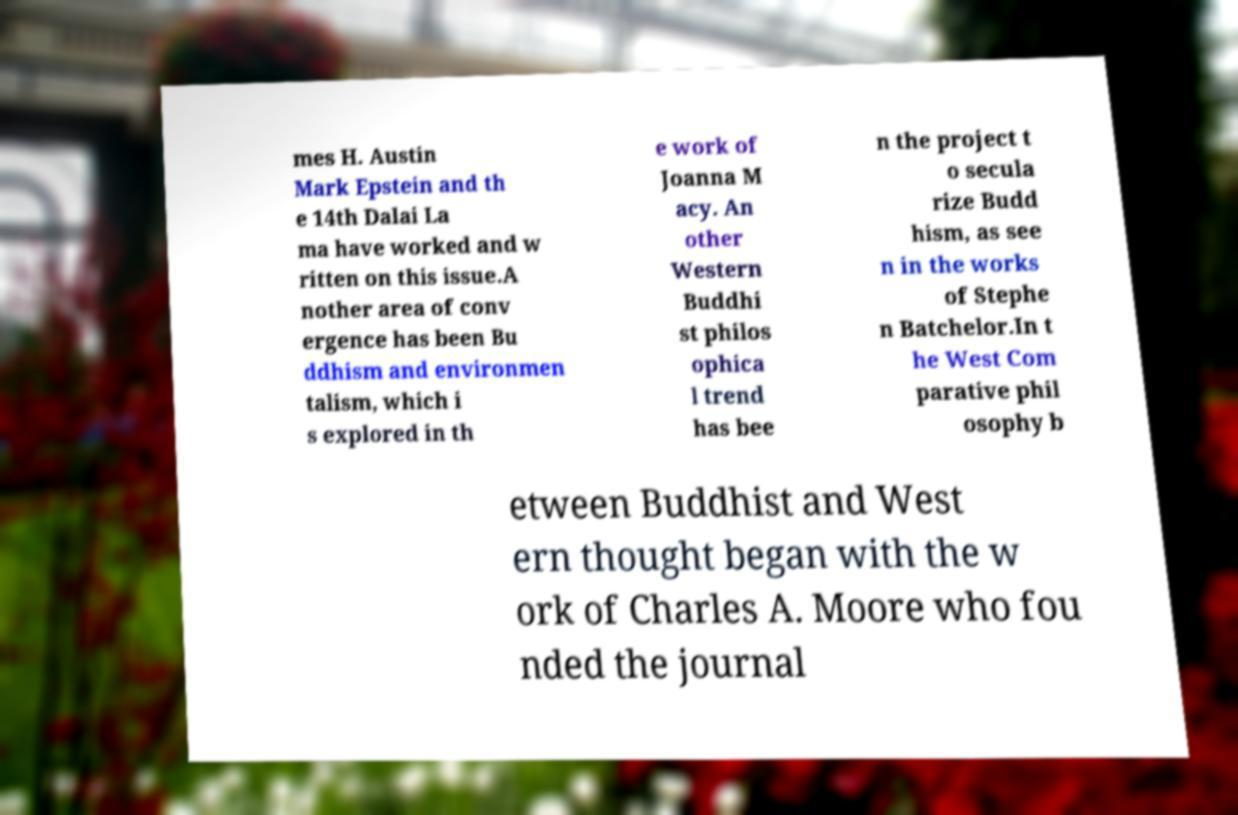There's text embedded in this image that I need extracted. Can you transcribe it verbatim? mes H. Austin Mark Epstein and th e 14th Dalai La ma have worked and w ritten on this issue.A nother area of conv ergence has been Bu ddhism and environmen talism, which i s explored in th e work of Joanna M acy. An other Western Buddhi st philos ophica l trend has bee n the project t o secula rize Budd hism, as see n in the works of Stephe n Batchelor.In t he West Com parative phil osophy b etween Buddhist and West ern thought began with the w ork of Charles A. Moore who fou nded the journal 